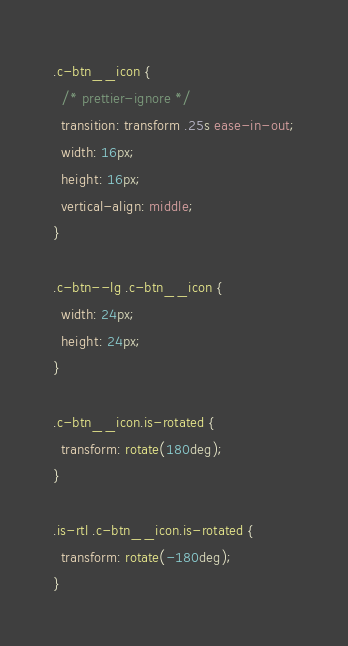Convert code to text. <code><loc_0><loc_0><loc_500><loc_500><_CSS_>.c-btn__icon {
  /* prettier-ignore */
  transition: transform .25s ease-in-out;
  width: 16px;
  height: 16px;
  vertical-align: middle;
}

.c-btn--lg .c-btn__icon {
  width: 24px;
  height: 24px;
}

.c-btn__icon.is-rotated {
  transform: rotate(180deg);
}

.is-rtl .c-btn__icon.is-rotated {
  transform: rotate(-180deg);
}
</code> 